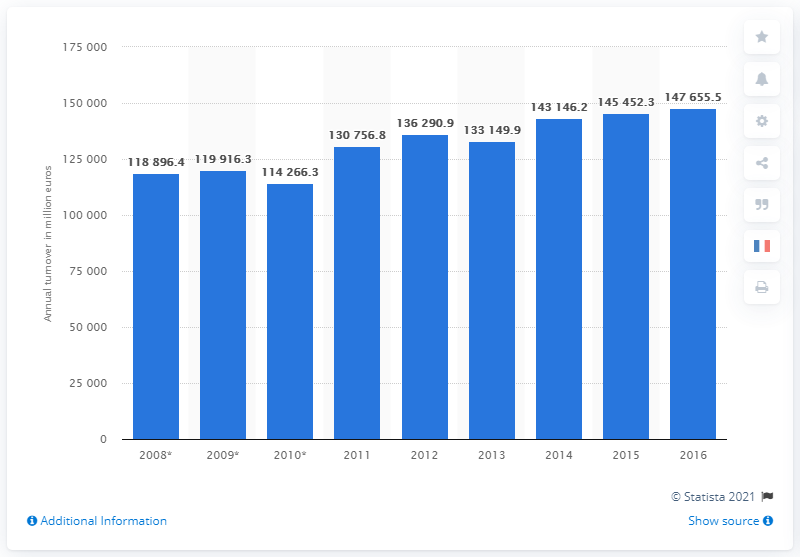Highlight a few significant elements in this photo. In 2016, the turnover of clothing and footwear wholesalers in the EU was 147,655.5. 